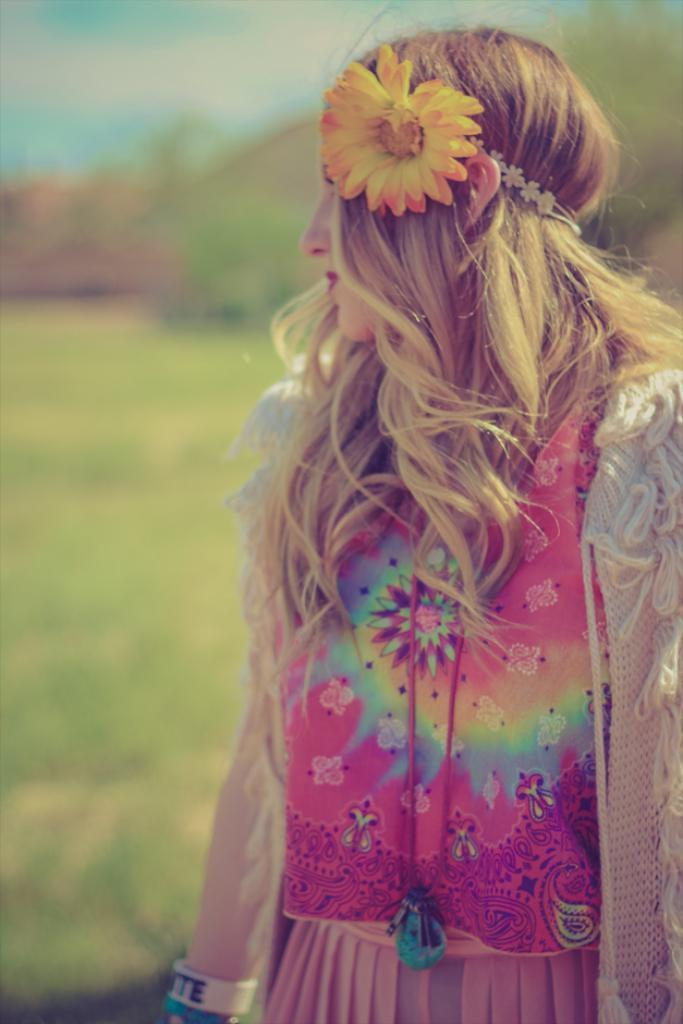Who is the main subject in the image? There is a woman in the image. What is on the woman's head? The woman has a flower on her head. What type of environment is visible in the background of the image? There is grassland in the background of the image, with trees present. What is visible at the top of the image? The sky is visible at the top of the image. What type of substance is the woman holding in the image? There is no substance visible in the woman's hands in the image. What type of stocking is the woman wearing in the image? There is no mention of stockings or any specific clothing items in the image, only the flower on her head. 